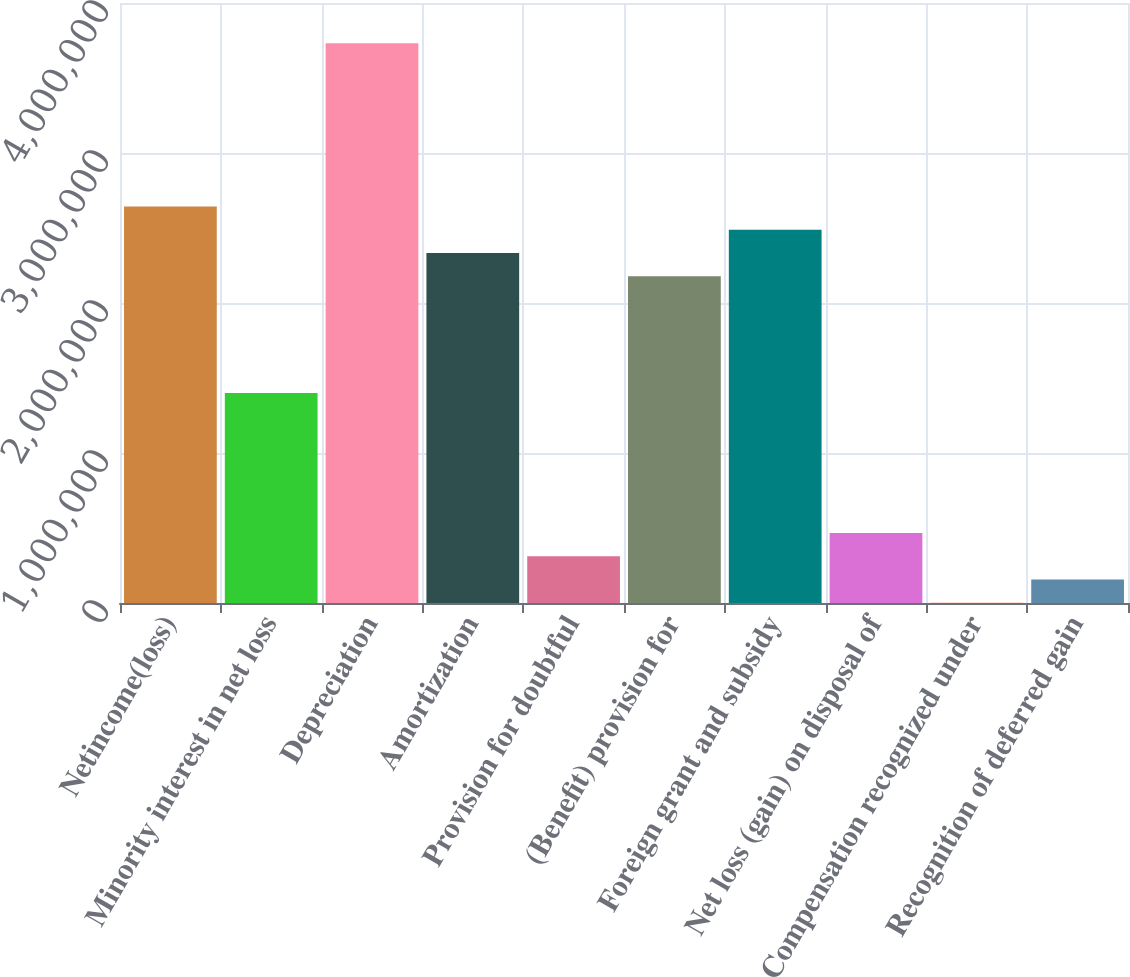Convert chart to OTSL. <chart><loc_0><loc_0><loc_500><loc_500><bar_chart><fcel>Netincome(loss)<fcel>Minority interest in net loss<fcel>Depreciation<fcel>Amortization<fcel>Provision for doubtful<fcel>(Benefit) provision for<fcel>Foreign grant and subsidy<fcel>Net loss (gain) on disposal of<fcel>Compensation recognized under<fcel>Recognition of deferred gain<nl><fcel>2.64412e+06<fcel>1.40031e+06<fcel>3.73246e+06<fcel>2.33317e+06<fcel>311968<fcel>2.17769e+06<fcel>2.48865e+06<fcel>467445<fcel>1014<fcel>156491<nl></chart> 